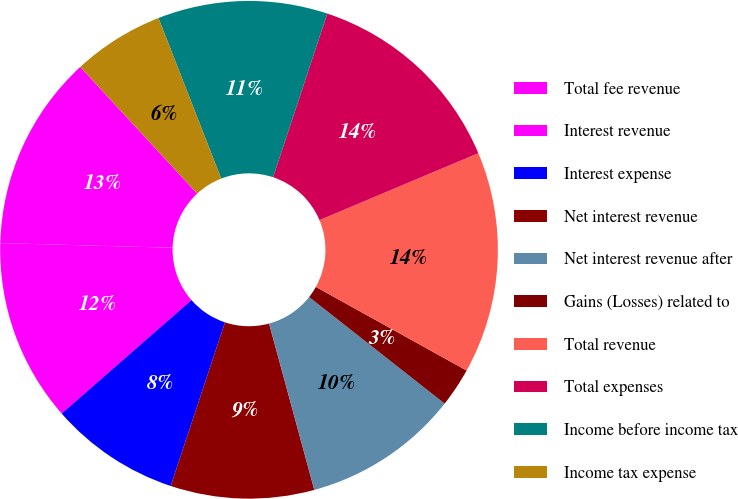Convert chart. <chart><loc_0><loc_0><loc_500><loc_500><pie_chart><fcel>Total fee revenue<fcel>Interest revenue<fcel>Interest expense<fcel>Net interest revenue<fcel>Net interest revenue after<fcel>Gains (Losses) related to<fcel>Total revenue<fcel>Total expenses<fcel>Income before income tax<fcel>Income tax expense<nl><fcel>12.71%<fcel>11.86%<fcel>8.47%<fcel>9.32%<fcel>10.17%<fcel>2.54%<fcel>14.41%<fcel>13.56%<fcel>11.02%<fcel>5.93%<nl></chart> 